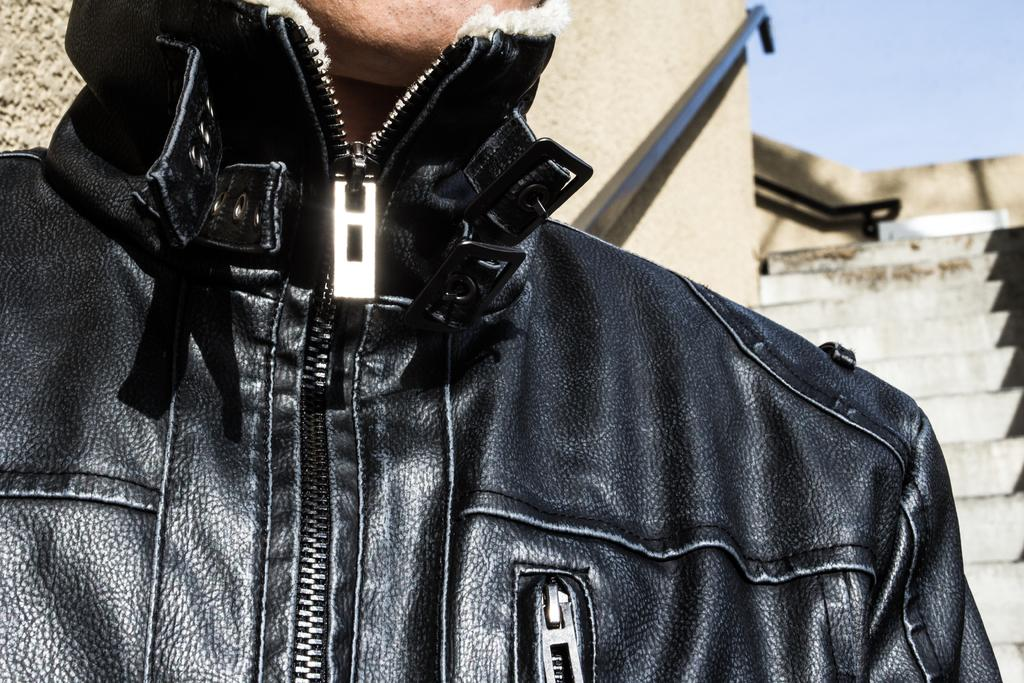Who or what is the main subject of the image? There is a person in the image. What is the person wearing? The person is wearing a black jacket. What can be seen in the background of the image? There are stairs visible in the background of the image. What is the color of the sky in the image? The sky is blue in color. What type of development can be seen in the image? There is no development project or construction site visible in the image; it features a person wearing a black jacket, stairs in the background, and a blue sky. What hobbies does the person in the image have? There is no information about the person's hobbies in the image. 